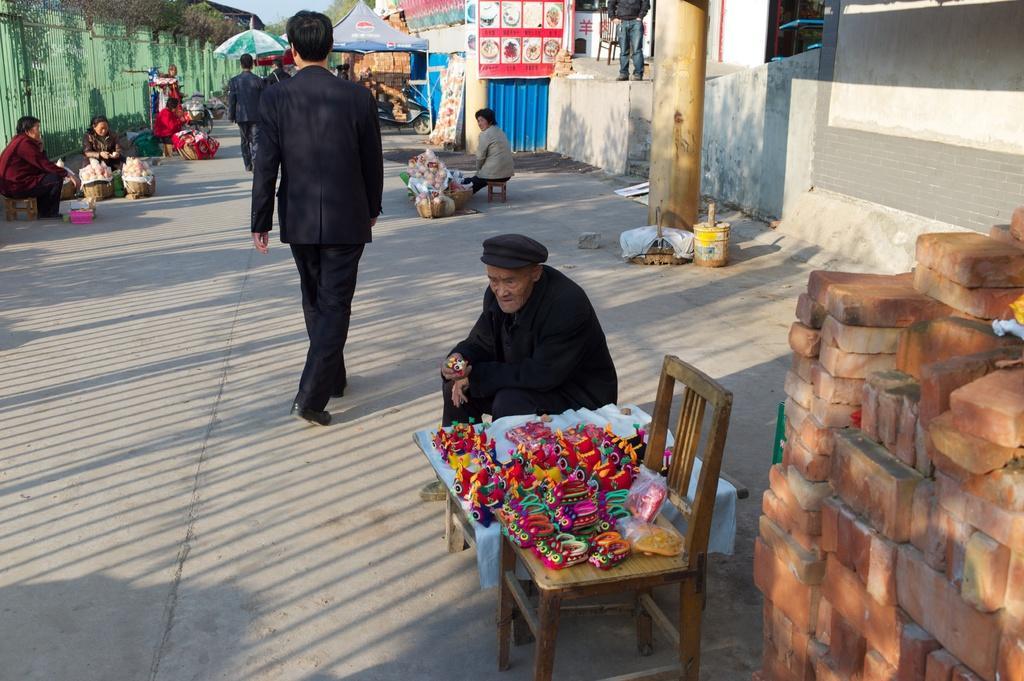In one or two sentences, can you explain what this image depicts? Here we can see a person is sitting and at side there are some objects on the chair, and a person is walking on the road, and here is the wall and here is the pillar, and here is he tent, and here is the tree. 